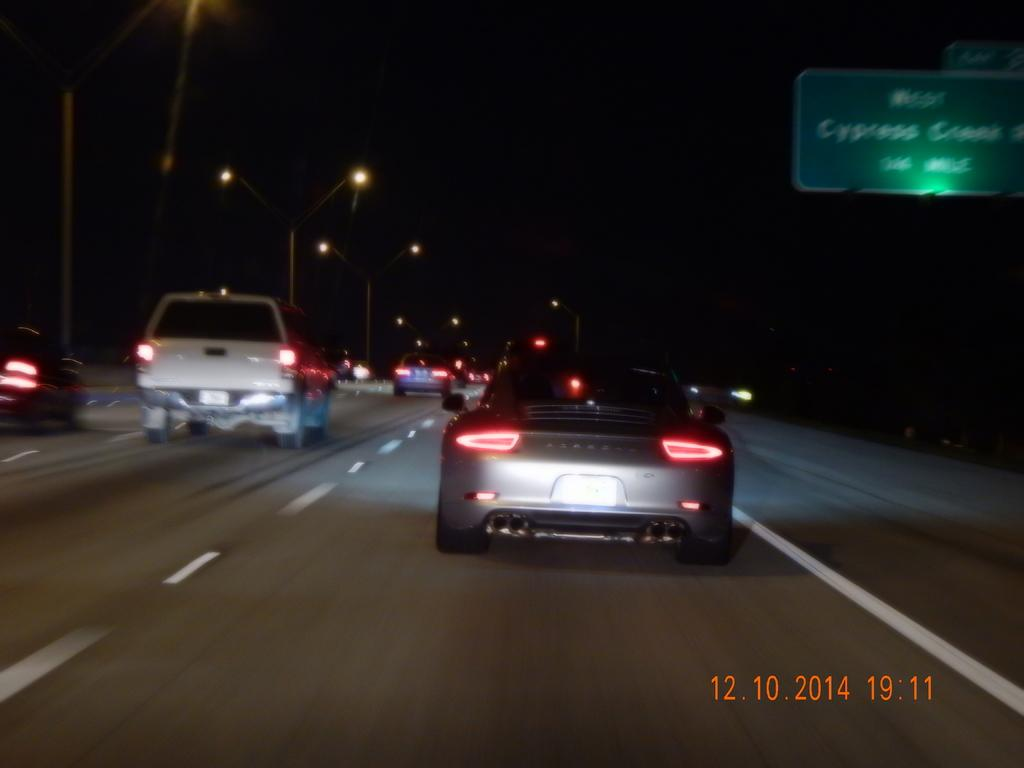What can be seen on the road in the image? There are vehicles on the road in the image. What else is visible in the image besides the vehicles? There are lights and poles visible in the image. What is the purpose of the board in the image? The purpose of the board in the image is not clear from the provided facts. What is the color of the background in the image? The background of the image is dark. What additional information is displayed in the image? The date and time are displayed in the bottom right corner of the image. How many cherries are on the secretary's desk in the image? There is no secretary or cherries present in the image. What type of debt is being discussed in the image? There is no discussion of debt in the image. 